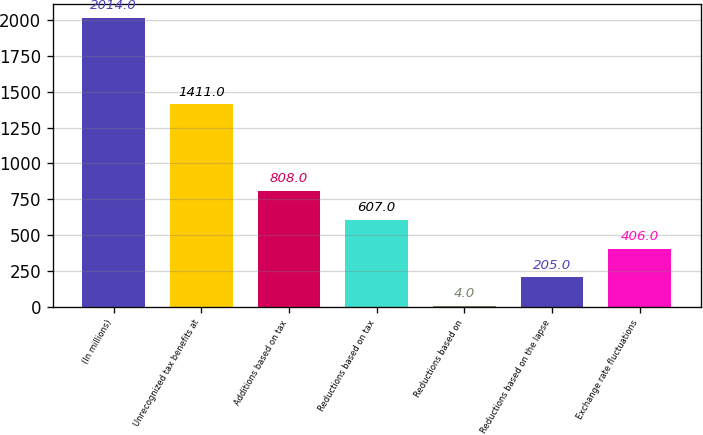Convert chart to OTSL. <chart><loc_0><loc_0><loc_500><loc_500><bar_chart><fcel>(In millions)<fcel>Unrecognized tax benefits at<fcel>Additions based on tax<fcel>Reductions based on tax<fcel>Reductions based on<fcel>Reductions based on the lapse<fcel>Exchange rate fluctuations<nl><fcel>2014<fcel>1411<fcel>808<fcel>607<fcel>4<fcel>205<fcel>406<nl></chart> 